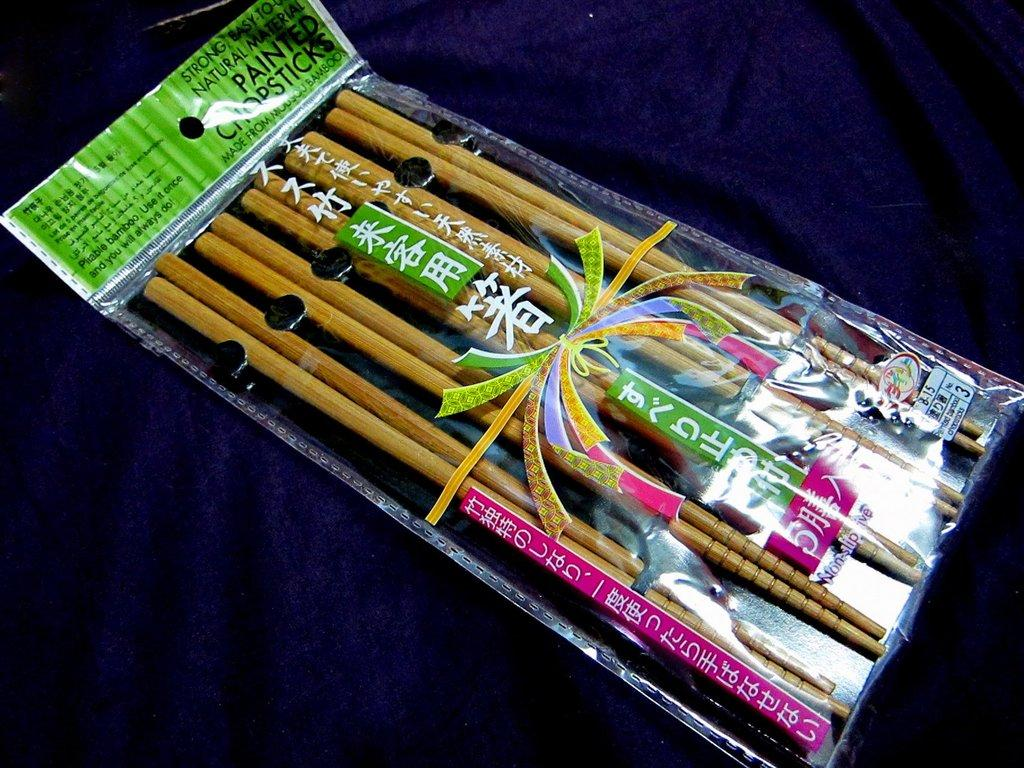What utensils can be seen in the image? There are chopsticks in the image. Where are the chopsticks located? The chopsticks are placed on a table. What type of pollution is visible in the image? There is no pollution visible in the image; it only features chopsticks placed on a table. 